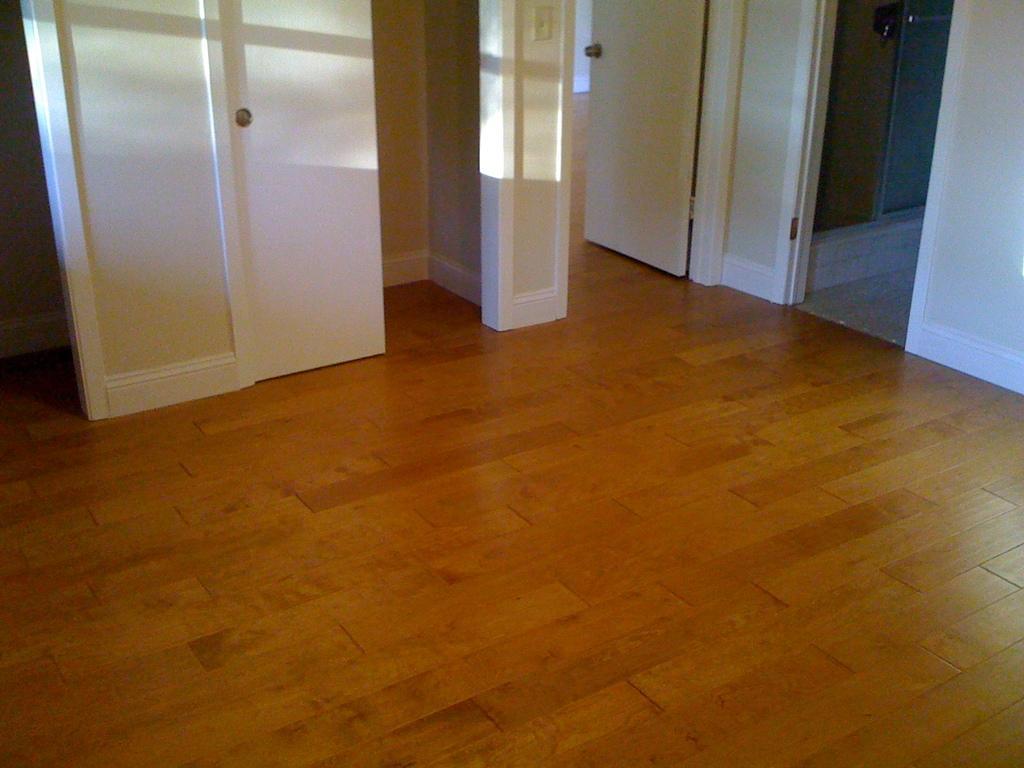Please provide a concise description of this image. In the picture I can see white color, wall and a wooden floor. 